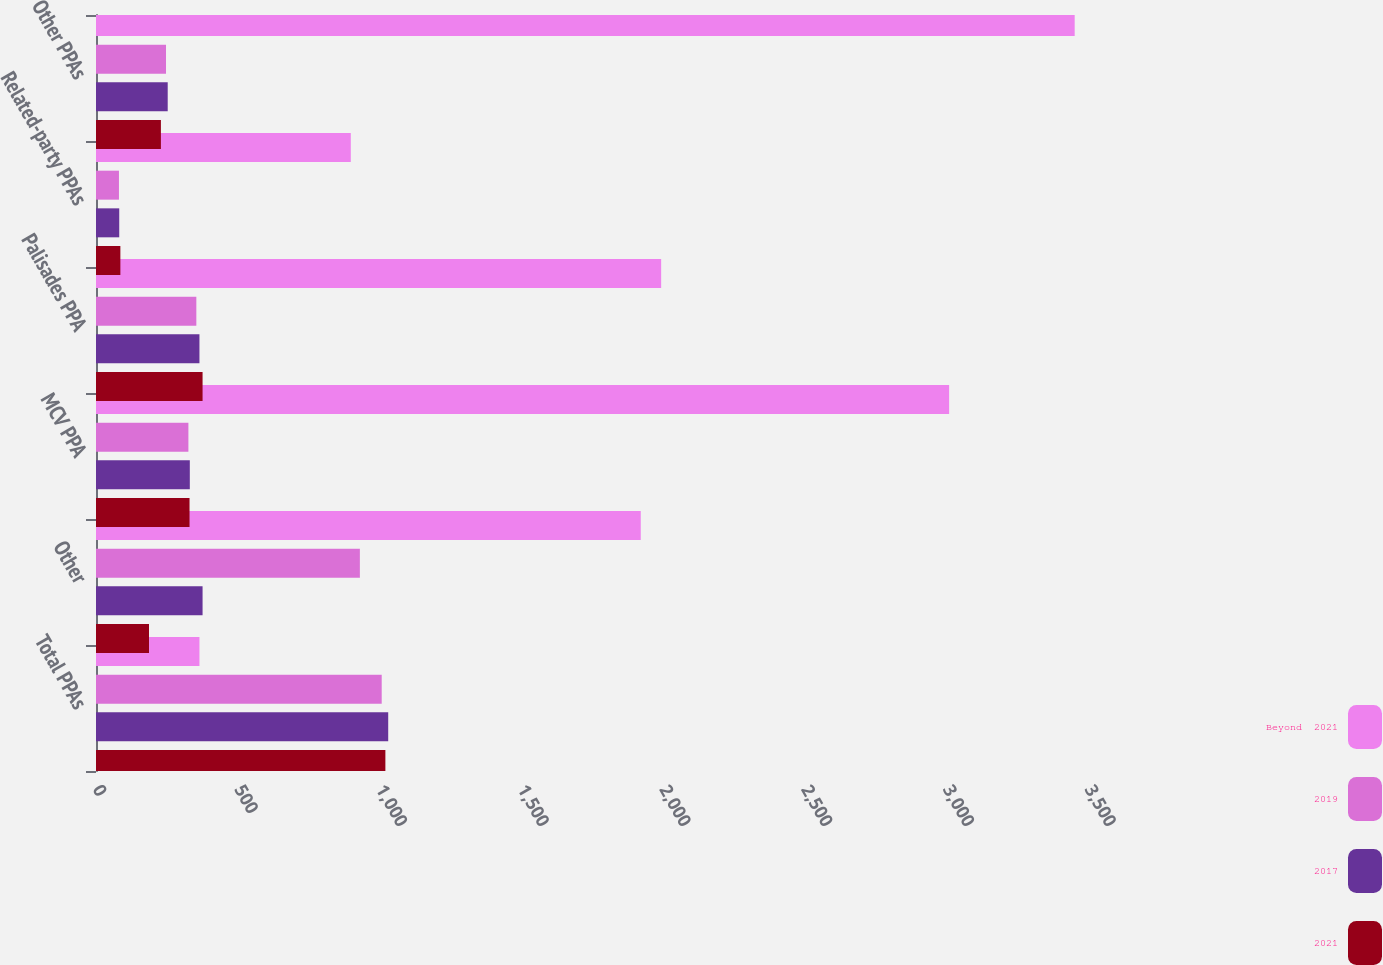<chart> <loc_0><loc_0><loc_500><loc_500><stacked_bar_chart><ecel><fcel>Total PPAs<fcel>Other<fcel>MCV PPA<fcel>Palisades PPA<fcel>Related-party PPAs<fcel>Other PPAs<nl><fcel>Beyond  2021<fcel>365<fcel>1922<fcel>3010<fcel>1994<fcel>899<fcel>3453<nl><fcel>2019<fcel>1008<fcel>931<fcel>326<fcel>354<fcel>81<fcel>247<nl><fcel>2017<fcel>1031<fcel>376<fcel>331<fcel>365<fcel>82<fcel>253<nl><fcel>2021<fcel>1021<fcel>187<fcel>330<fcel>376<fcel>86<fcel>229<nl></chart> 